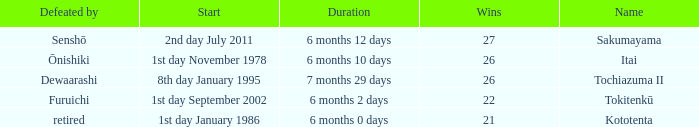How many wins, on average, were defeated by furuichi? 22.0. 